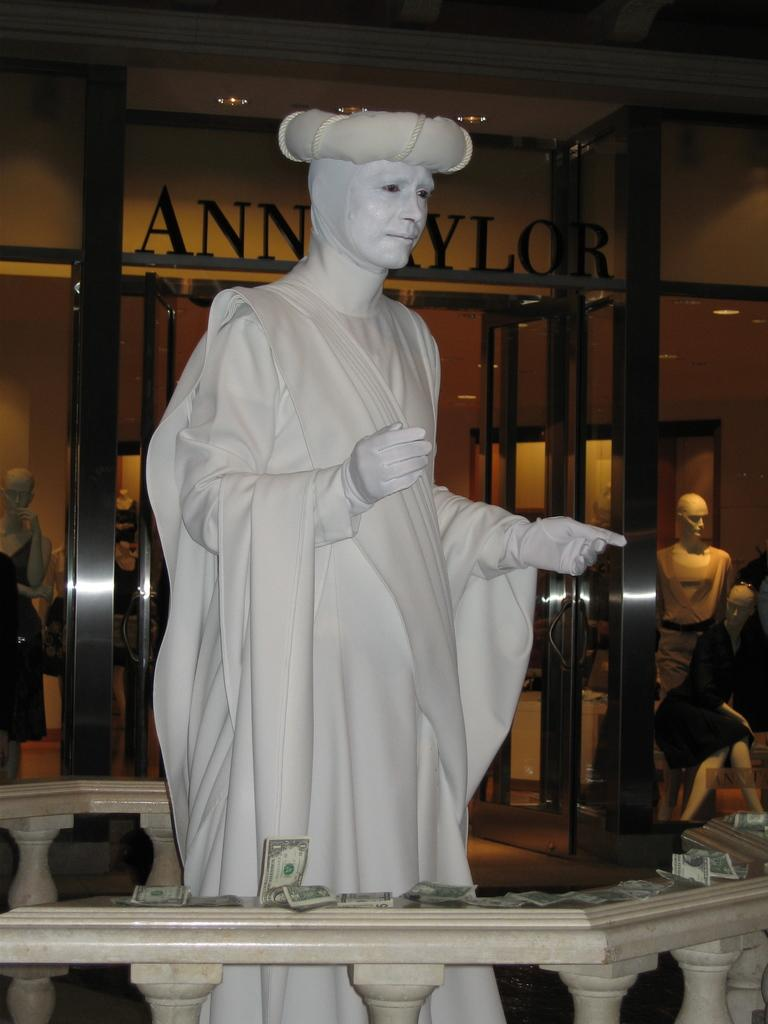What is the main subject in the image? There is a statue in the image. What other objects can be seen in the image? There are mannequins in the image. What can be seen in the background of the image? There are glasses, a board, and lights in the background of the image. How does the statue's knee twist in the image? The statue does not have a knee, nor does it twist, as it is a non-living object. 